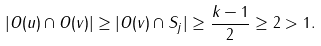Convert formula to latex. <formula><loc_0><loc_0><loc_500><loc_500>| O ( u ) \cap O ( v ) | \geq | O ( v ) \cap S _ { j } | \geq \frac { k - 1 } { 2 } \geq 2 > 1 .</formula> 